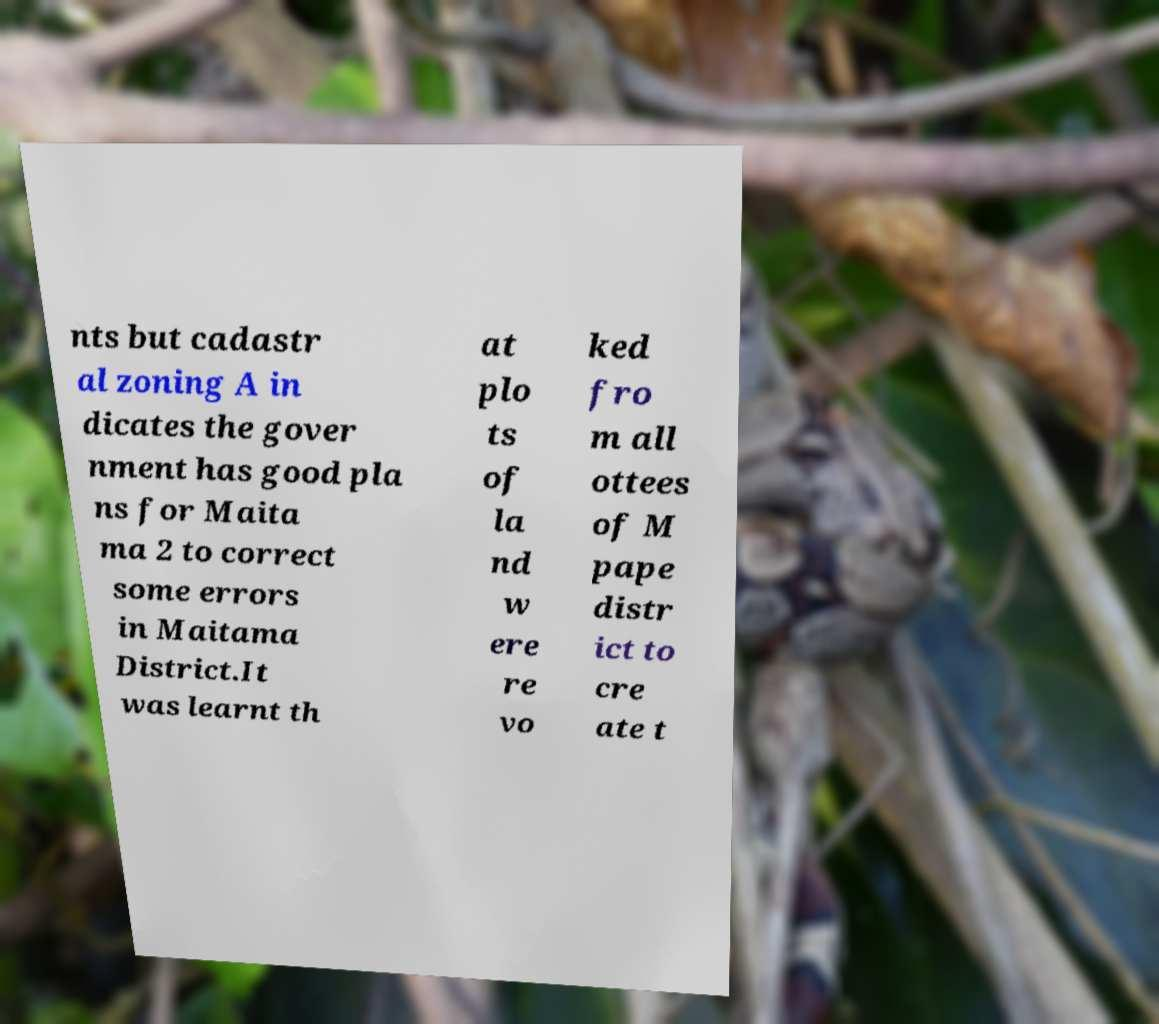What messages or text are displayed in this image? I need them in a readable, typed format. nts but cadastr al zoning A in dicates the gover nment has good pla ns for Maita ma 2 to correct some errors in Maitama District.It was learnt th at plo ts of la nd w ere re vo ked fro m all ottees of M pape distr ict to cre ate t 